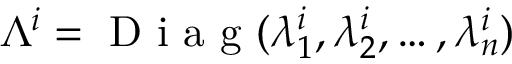<formula> <loc_0><loc_0><loc_500><loc_500>\Lambda ^ { i } = D i a g ( \lambda _ { 1 } ^ { i } , \lambda _ { 2 } ^ { i } , \dots , \lambda _ { n } ^ { i } )</formula> 